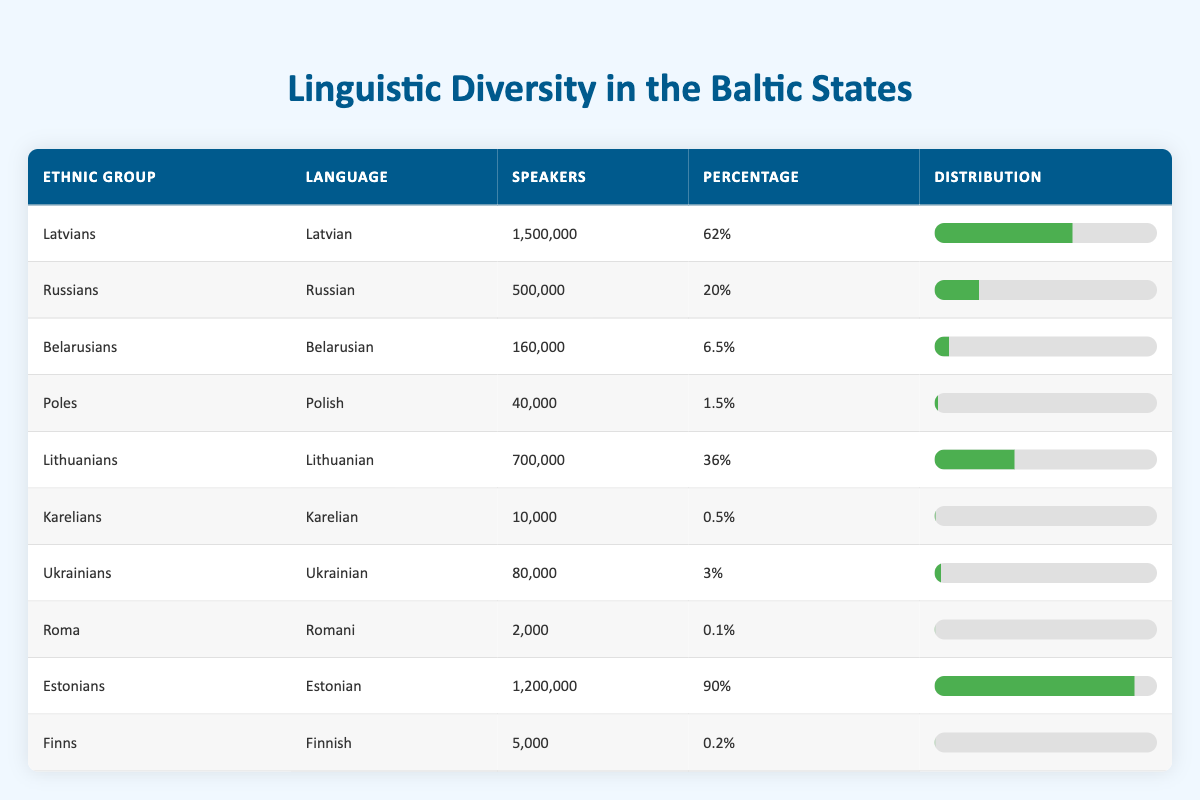What is the total number of speakers among all ethnic groups in the table? To find the total speakers, we add the number of speakers across all ethnic groups: 1,500,000 (Latvians) + 500,000 (Russians) + 160,000 (Belarusians) + 40,000 (Poles) + 700,000 (Lithuanians) + 10,000 (Karelians) + 80,000 (Ukrainians) + 2,000 (Roma) + 1,200,000 (Estonians) + 5,000 (Finns) = 4,037,000
Answer: 4,037,000 Which ethnic group has the highest percentage of speakers? By looking at the percentage column, we can compare the values. Estonians have the highest percentage at 90%.
Answer: Estonians How many speakers are there for the Russian language? The table directly states that the number of speakers for the Russian language is 500,000.
Answer: 500,000 Are there more speakers of Latvian than Lithuanian languages combined? The speakers of Latvian are 1,500,000 and Lithuanian are 700,000. Adding Lithuanian's speakers gives us 1,500,000 > (1,500,000 vs (700,000)). Thus, the answer is yes.
Answer: Yes What is the average percentage of speakers for the ethnic groups listed? To calculate the average percentage, we total the percentages (62 + 20 + 6.5 + 1.5 + 36 + 0.5 + 3 + 0.1 + 90 + 0.2) = 220.3%. Then divide by the number of groups, which is 10: 220.3 / 10 = 22.03%.
Answer: 22.03% Do any ethnic groups have less than 1% of speakers? We can check the percentage column for values below 1%. Karelians (0.5%), Roma (0.1%), and Finns (0.2%) are below 1%.
Answer: Yes How many ethnic groups have percentages greater than 20%? Inspecting the percentage column, the groups with percentages greater than 20% are Latvians (62%), Russians (20%), Lithuanians (36%), and Estonians (90%), totaling 4 groups.
Answer: 4 What percentage of speakers do Ukrainians represent in the overall distribution? The percentage of speakers for Ukrainians is given directly in the table as 3%.
Answer: 3% Is the number of speakers of Karelian language higher than that of Polish language? Karelian has 10,000 speakers while Polish has 40,000, which is less. So, the answer is no.
Answer: No 